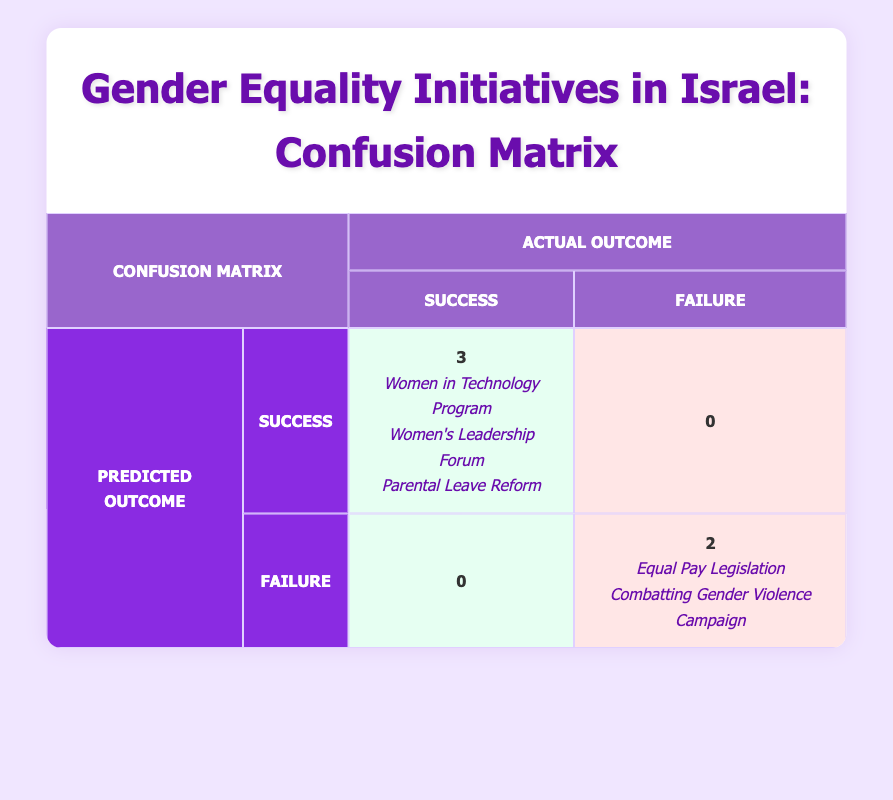What is the total number of initiatives categorized as successful? The table shows three initiatives marked as successful: the Women in Technology Program, Women's Leadership Forum, and Parental Leave Reform. Thus, the total count is simply 3.
Answer: 3 How many initiatives were launched after 2018 and classified as failures? The initiatives launched after 2018 are the Equal Pay Legislation (2020) and Parental Leave Reform (2021). Of these, only the Equal Pay Legislation is marked as a failure. Therefore, the answer is 1.
Answer: 1 What percentage of initiatives predicted as successful were actually successful? There are 3 initiatives, and all 3 predicted as successful were indeed successful. To find the percentage, we apply the formula (3 actual successful / 3 predicted successful) * 100 = 100%. Thus, the percentage is 100%.
Answer: 100% Did the Combatting Gender Violence Campaign exceed its participant goals? The table indicates that the Combatting Gender Violence Campaign had 50 participants exceeding goals, which does not meet or exceed the defined success criteria of exceeding goals. Therefore, the answer is no.
Answer: No What is the difference in the number of initiatives that exceeded goals between successful and failed categories? Successful initiatives exceeded goals by 150 (Women in Technology Program) + 300 (Women's Leadership Forum) + 200 (Parental Leave Reform) = 650. Failed initiatives, namely Equal Pay Legislation and Combatting Gender Violence Campaign, had 0 and 50 exceeding goals, respectively, giving a total of 50. The difference is 650 - 50 = 600.
Answer: 600 How many initiatives were there in total? The table lists five distinct initiatives: Women in Technology Program, Equal Pay Legislation, Women's Leadership Forum, Combatting Gender Violence Campaign, and Parental Leave Reform. Therefore, the total number is 5.
Answer: 5 Were there any initiatives that were predicted as failures but classified as successful? According to the table, there are no initiatives that were both predicted as failures and classified as successful, as both successful initiatives were correctly classified. Thus, the answer is no.
Answer: No What is the average number of participants exceeding goals for successful initiatives? The successful initiatives saw 150 (from Women in Technology Program) + 300 (from Women's Leadership Forum) + 200 (from Parental Leave Reform), totaling 650 participants. Since there are 3 successful initiatives, the average is 650 / 3 = approximately 216.67.
Answer: 216.67 